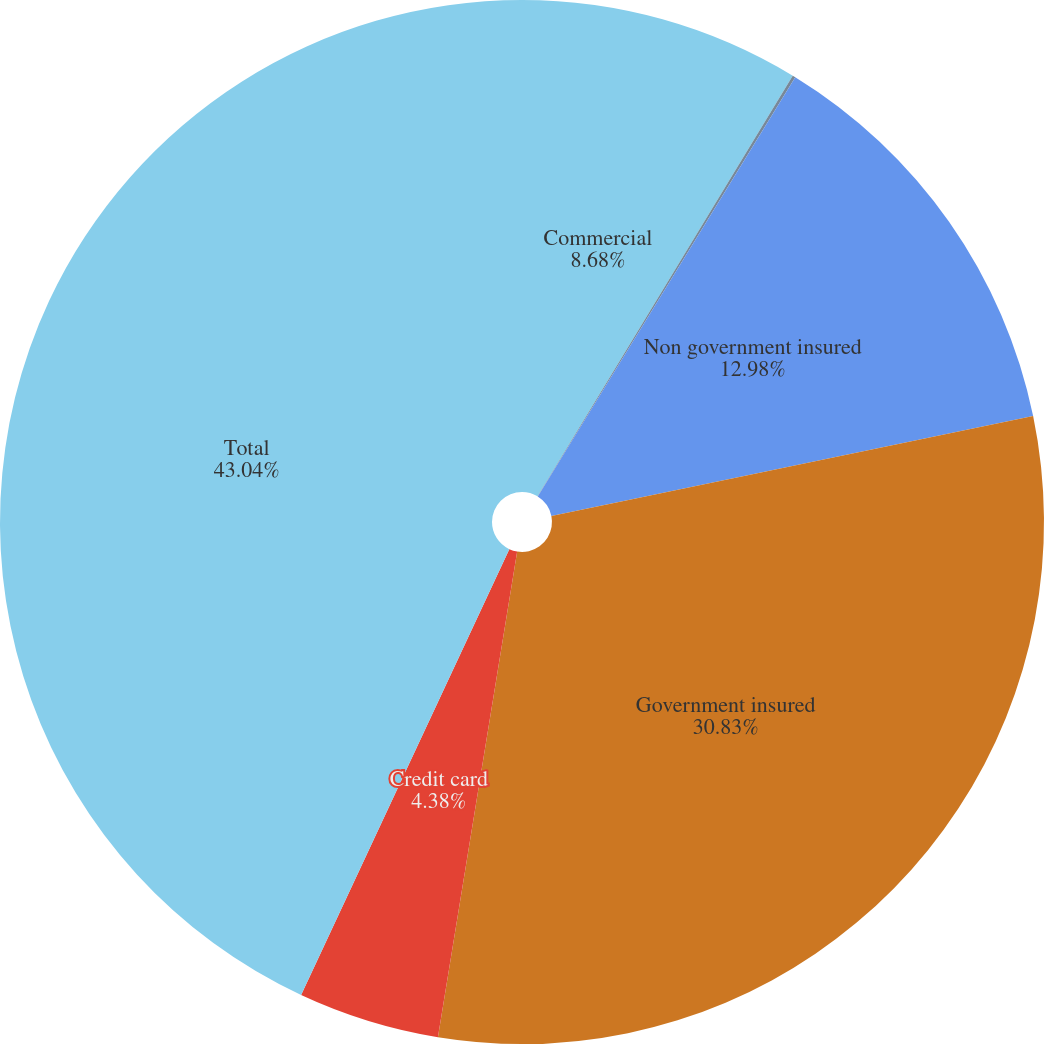<chart> <loc_0><loc_0><loc_500><loc_500><pie_chart><fcel>Commercial<fcel>Commercial real estate<fcel>Non government insured<fcel>Government insured<fcel>Credit card<fcel>Total<nl><fcel>8.68%<fcel>0.09%<fcel>12.98%<fcel>30.83%<fcel>4.38%<fcel>43.05%<nl></chart> 